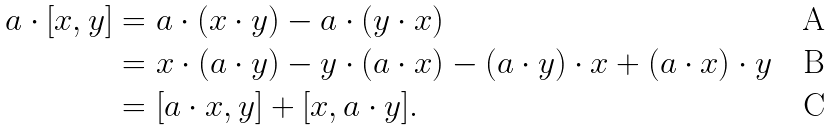<formula> <loc_0><loc_0><loc_500><loc_500>a \cdot [ x , y ] & = a \cdot ( x \cdot y ) - a \cdot ( y \cdot x ) \\ & = x \cdot ( a \cdot y ) - y \cdot ( a \cdot x ) - ( a \cdot y ) \cdot x + ( a \cdot x ) \cdot y \\ & = [ a \cdot x , y ] + [ x , a \cdot y ] .</formula> 